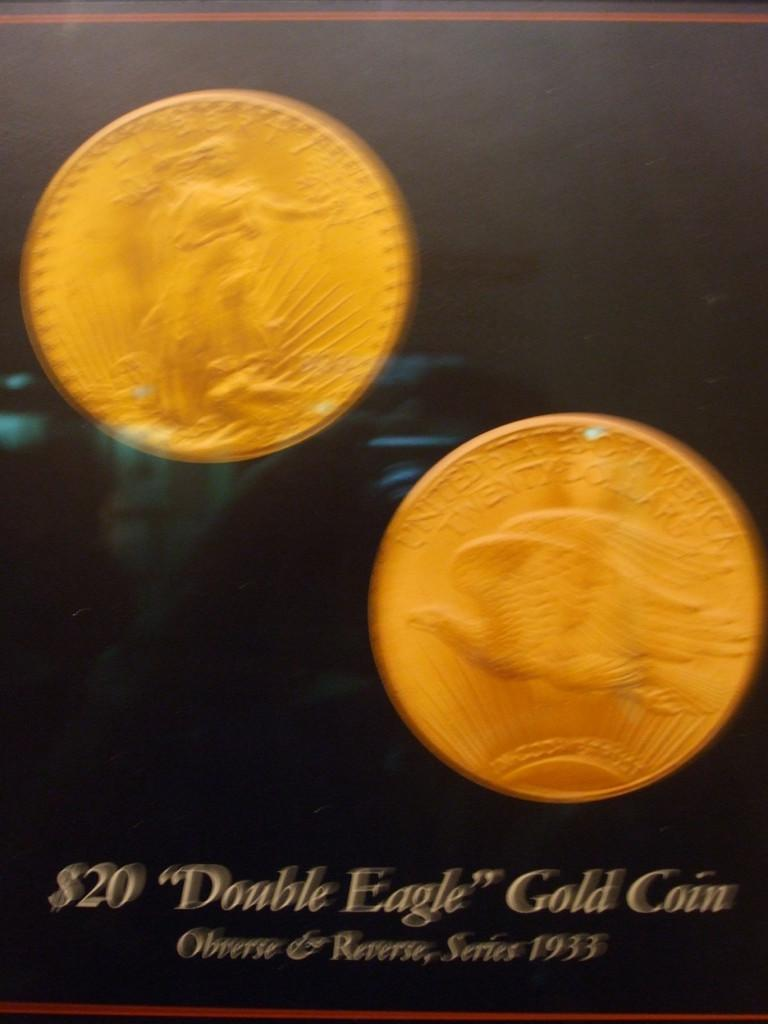<image>
Give a short and clear explanation of the subsequent image. a poster that says '$20 "Double Eagle" Gold Coin' on it 